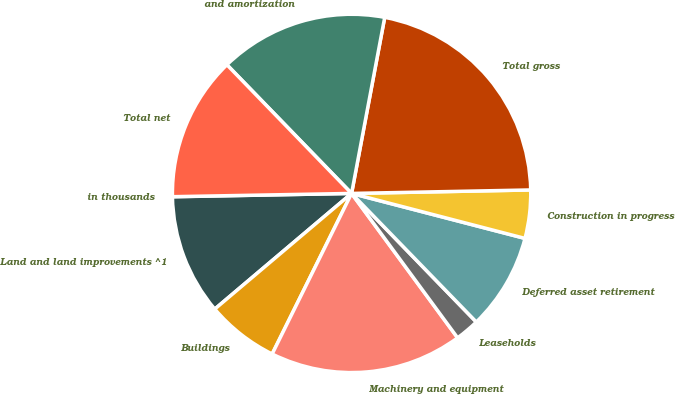Convert chart. <chart><loc_0><loc_0><loc_500><loc_500><pie_chart><fcel>in thousands<fcel>Land and land improvements ^1<fcel>Buildings<fcel>Machinery and equipment<fcel>Leaseholds<fcel>Deferred asset retirement<fcel>Construction in progress<fcel>Total gross<fcel>and amortization<fcel>Total net<nl><fcel>0.01%<fcel>10.87%<fcel>6.52%<fcel>17.39%<fcel>2.18%<fcel>8.7%<fcel>4.35%<fcel>21.73%<fcel>15.21%<fcel>13.04%<nl></chart> 